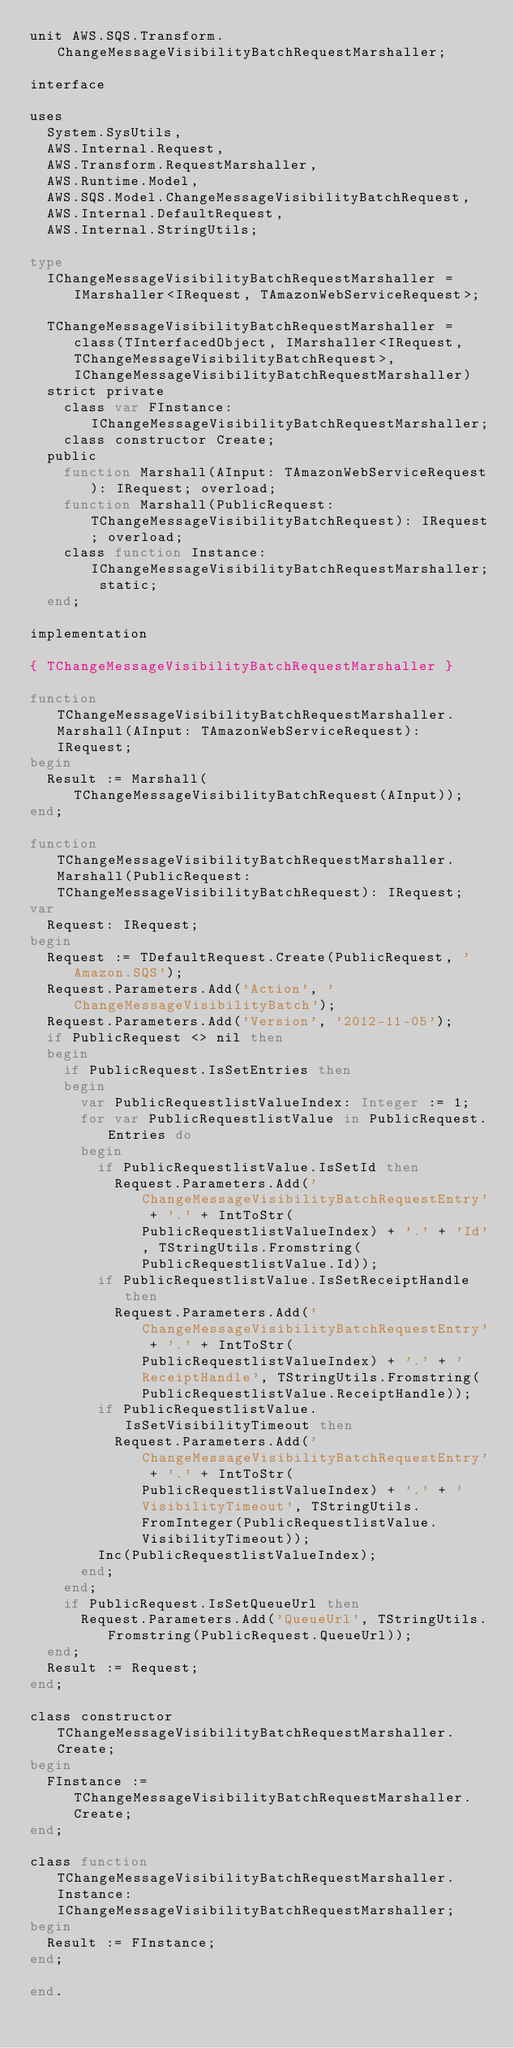Convert code to text. <code><loc_0><loc_0><loc_500><loc_500><_Pascal_>unit AWS.SQS.Transform.ChangeMessageVisibilityBatchRequestMarshaller;

interface

uses
  System.SysUtils, 
  AWS.Internal.Request, 
  AWS.Transform.RequestMarshaller, 
  AWS.Runtime.Model, 
  AWS.SQS.Model.ChangeMessageVisibilityBatchRequest, 
  AWS.Internal.DefaultRequest, 
  AWS.Internal.StringUtils;

type
  IChangeMessageVisibilityBatchRequestMarshaller = IMarshaller<IRequest, TAmazonWebServiceRequest>;
  
  TChangeMessageVisibilityBatchRequestMarshaller = class(TInterfacedObject, IMarshaller<IRequest, TChangeMessageVisibilityBatchRequest>, IChangeMessageVisibilityBatchRequestMarshaller)
  strict private
    class var FInstance: IChangeMessageVisibilityBatchRequestMarshaller;
    class constructor Create;
  public
    function Marshall(AInput: TAmazonWebServiceRequest): IRequest; overload;
    function Marshall(PublicRequest: TChangeMessageVisibilityBatchRequest): IRequest; overload;
    class function Instance: IChangeMessageVisibilityBatchRequestMarshaller; static;
  end;
  
implementation

{ TChangeMessageVisibilityBatchRequestMarshaller }

function TChangeMessageVisibilityBatchRequestMarshaller.Marshall(AInput: TAmazonWebServiceRequest): IRequest;
begin
  Result := Marshall(TChangeMessageVisibilityBatchRequest(AInput));
end;

function TChangeMessageVisibilityBatchRequestMarshaller.Marshall(PublicRequest: TChangeMessageVisibilityBatchRequest): IRequest;
var
  Request: IRequest;
begin
  Request := TDefaultRequest.Create(PublicRequest, 'Amazon.SQS');
  Request.Parameters.Add('Action', 'ChangeMessageVisibilityBatch');
  Request.Parameters.Add('Version', '2012-11-05');
  if PublicRequest <> nil then
  begin
    if PublicRequest.IsSetEntries then
    begin
      var PublicRequestlistValueIndex: Integer := 1;
      for var PublicRequestlistValue in PublicRequest.Entries do
      begin
        if PublicRequestlistValue.IsSetId then
          Request.Parameters.Add('ChangeMessageVisibilityBatchRequestEntry' + '.' + IntToStr(PublicRequestlistValueIndex) + '.' + 'Id', TStringUtils.Fromstring(PublicRequestlistValue.Id));
        if PublicRequestlistValue.IsSetReceiptHandle then
          Request.Parameters.Add('ChangeMessageVisibilityBatchRequestEntry' + '.' + IntToStr(PublicRequestlistValueIndex) + '.' + 'ReceiptHandle', TStringUtils.Fromstring(PublicRequestlistValue.ReceiptHandle));
        if PublicRequestlistValue.IsSetVisibilityTimeout then
          Request.Parameters.Add('ChangeMessageVisibilityBatchRequestEntry' + '.' + IntToStr(PublicRequestlistValueIndex) + '.' + 'VisibilityTimeout', TStringUtils.FromInteger(PublicRequestlistValue.VisibilityTimeout));
        Inc(PublicRequestlistValueIndex);
      end;
    end;
    if PublicRequest.IsSetQueueUrl then
      Request.Parameters.Add('QueueUrl', TStringUtils.Fromstring(PublicRequest.QueueUrl));
  end;
  Result := Request;
end;

class constructor TChangeMessageVisibilityBatchRequestMarshaller.Create;
begin
  FInstance := TChangeMessageVisibilityBatchRequestMarshaller.Create;
end;

class function TChangeMessageVisibilityBatchRequestMarshaller.Instance: IChangeMessageVisibilityBatchRequestMarshaller;
begin
  Result := FInstance;
end;

end.
</code> 